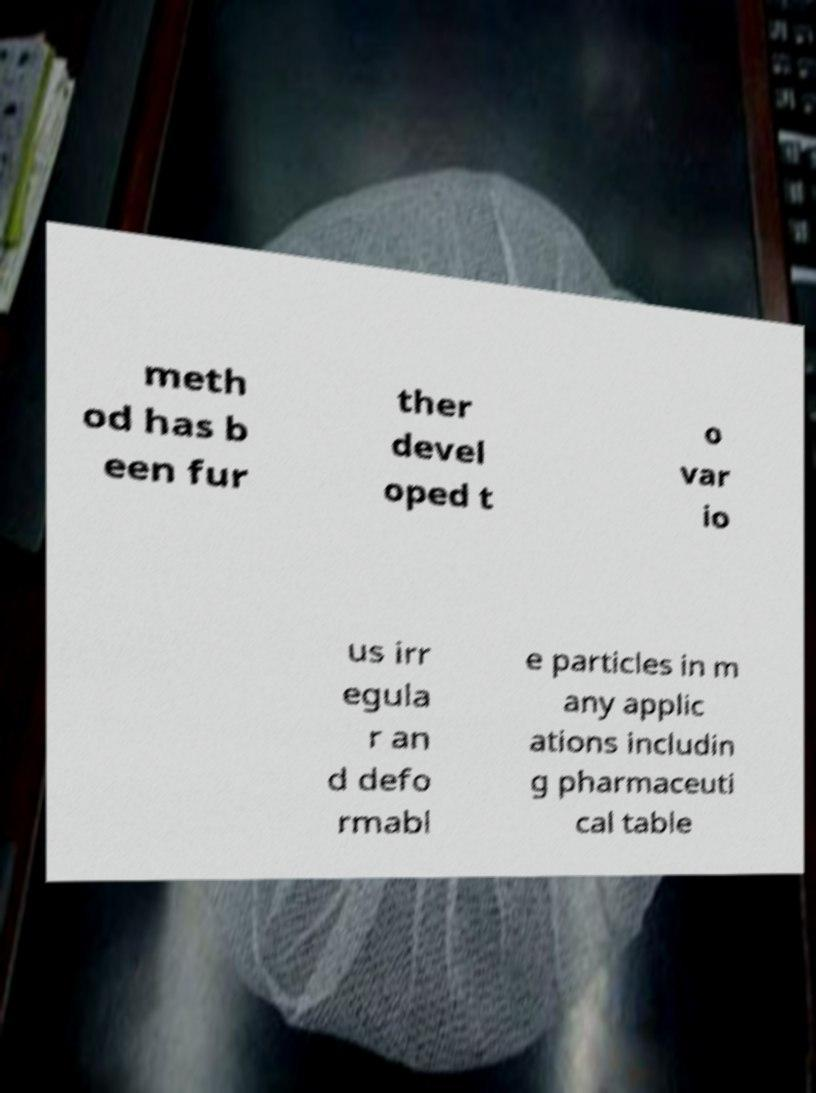Can you read and provide the text displayed in the image?This photo seems to have some interesting text. Can you extract and type it out for me? meth od has b een fur ther devel oped t o var io us irr egula r an d defo rmabl e particles in m any applic ations includin g pharmaceuti cal table 